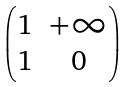<formula> <loc_0><loc_0><loc_500><loc_500>\begin{pmatrix} 1 & + \infty \\ 1 & 0 \end{pmatrix}</formula> 